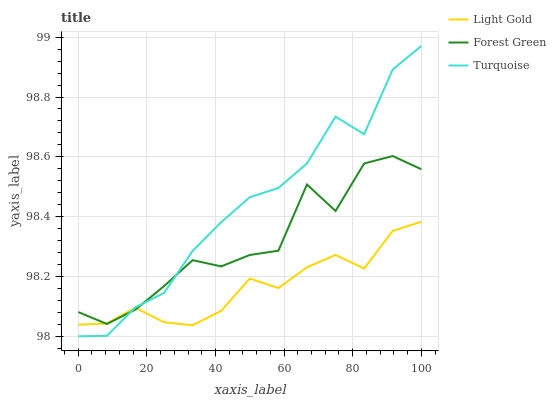Does Light Gold have the minimum area under the curve?
Answer yes or no. Yes. Does Turquoise have the maximum area under the curve?
Answer yes or no. Yes. Does Turquoise have the minimum area under the curve?
Answer yes or no. No. Does Light Gold have the maximum area under the curve?
Answer yes or no. No. Is Light Gold the smoothest?
Answer yes or no. Yes. Is Forest Green the roughest?
Answer yes or no. Yes. Is Turquoise the smoothest?
Answer yes or no. No. Is Turquoise the roughest?
Answer yes or no. No. Does Turquoise have the lowest value?
Answer yes or no. Yes. Does Light Gold have the lowest value?
Answer yes or no. No. Does Turquoise have the highest value?
Answer yes or no. Yes. Does Light Gold have the highest value?
Answer yes or no. No. Does Forest Green intersect Turquoise?
Answer yes or no. Yes. Is Forest Green less than Turquoise?
Answer yes or no. No. Is Forest Green greater than Turquoise?
Answer yes or no. No. 